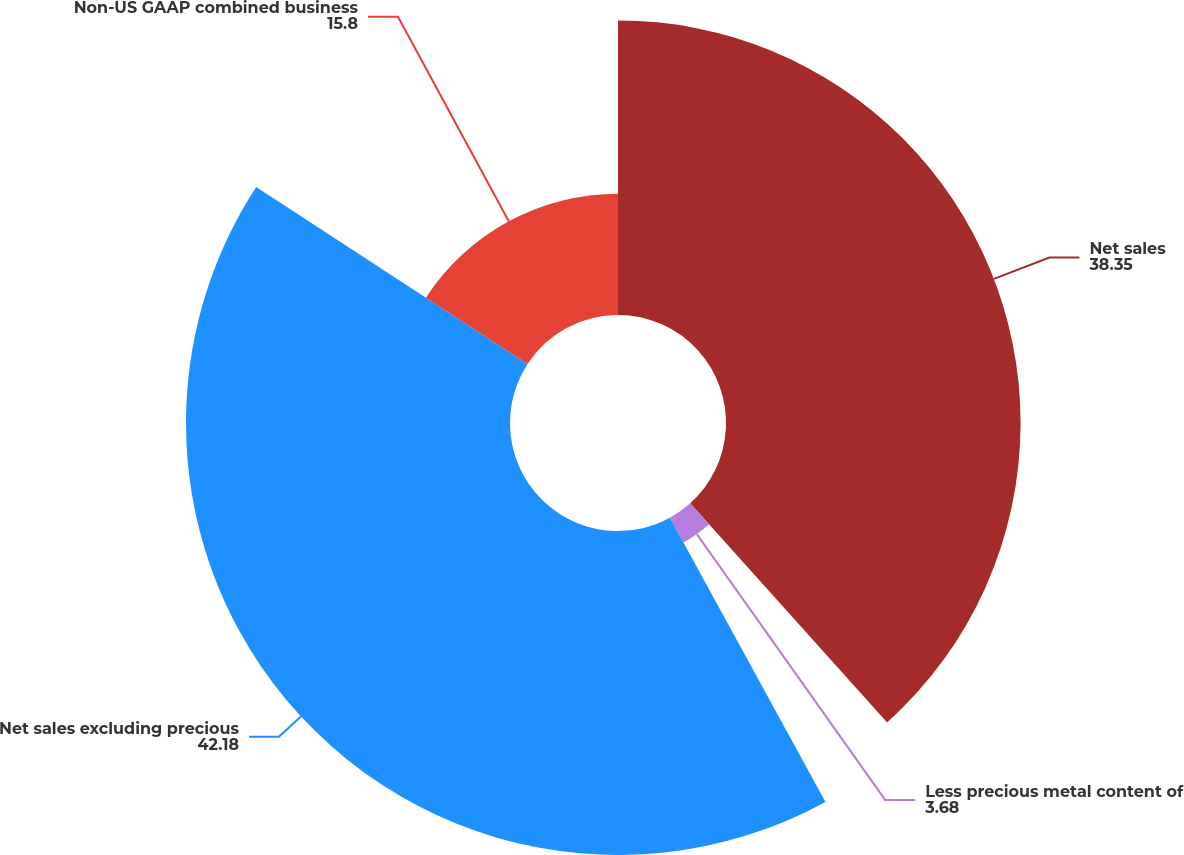Convert chart. <chart><loc_0><loc_0><loc_500><loc_500><pie_chart><fcel>Net sales<fcel>Less precious metal content of<fcel>Net sales excluding precious<fcel>Non-US GAAP combined business<nl><fcel>38.35%<fcel>3.68%<fcel>42.18%<fcel>15.8%<nl></chart> 